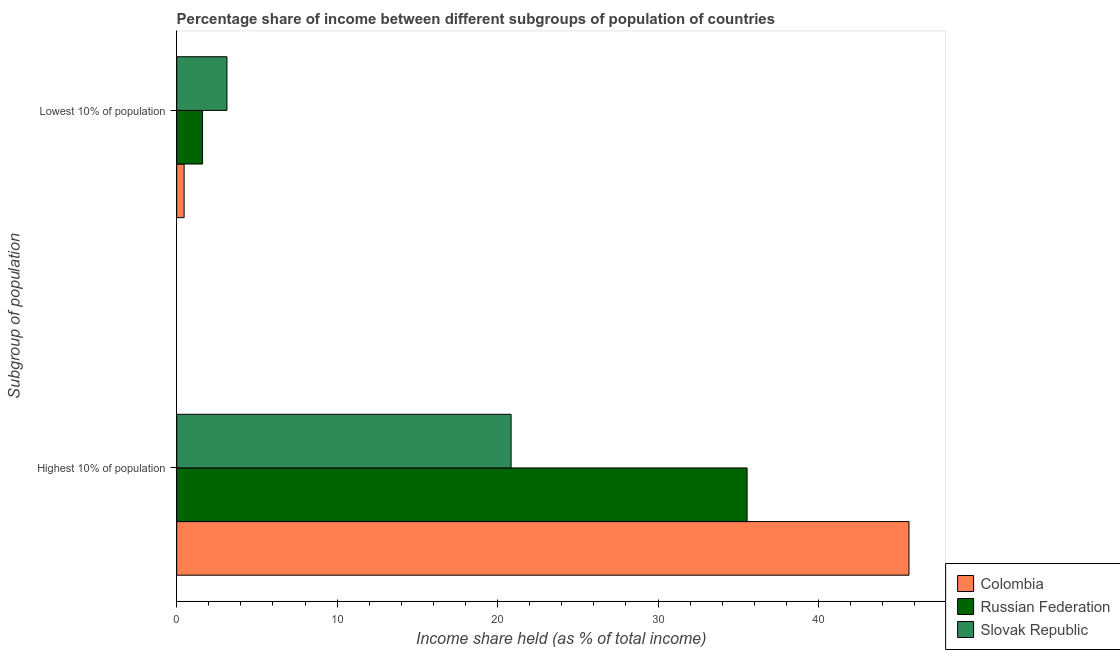How many different coloured bars are there?
Offer a terse response. 3. How many groups of bars are there?
Give a very brief answer. 2. What is the label of the 2nd group of bars from the top?
Give a very brief answer. Highest 10% of population. What is the income share held by highest 10% of the population in Russian Federation?
Keep it short and to the point. 35.55. Across all countries, what is the maximum income share held by highest 10% of the population?
Give a very brief answer. 45.64. Across all countries, what is the minimum income share held by highest 10% of the population?
Your response must be concise. 20.84. In which country was the income share held by lowest 10% of the population maximum?
Give a very brief answer. Slovak Republic. In which country was the income share held by highest 10% of the population minimum?
Keep it short and to the point. Slovak Republic. What is the total income share held by highest 10% of the population in the graph?
Your response must be concise. 102.03. What is the difference between the income share held by highest 10% of the population in Slovak Republic and that in Colombia?
Your response must be concise. -24.8. What is the difference between the income share held by lowest 10% of the population in Slovak Republic and the income share held by highest 10% of the population in Colombia?
Provide a short and direct response. -42.51. What is the average income share held by lowest 10% of the population per country?
Provide a short and direct response. 1.73. What is the difference between the income share held by highest 10% of the population and income share held by lowest 10% of the population in Slovak Republic?
Offer a terse response. 17.71. In how many countries, is the income share held by highest 10% of the population greater than 32 %?
Offer a very short reply. 2. What is the ratio of the income share held by highest 10% of the population in Colombia to that in Slovak Republic?
Offer a terse response. 2.19. Is the income share held by lowest 10% of the population in Slovak Republic less than that in Russian Federation?
Your response must be concise. No. What does the 1st bar from the top in Lowest 10% of population represents?
Provide a short and direct response. Slovak Republic. What does the 1st bar from the bottom in Lowest 10% of population represents?
Keep it short and to the point. Colombia. How many countries are there in the graph?
Your answer should be very brief. 3. What is the difference between two consecutive major ticks on the X-axis?
Make the answer very short. 10. Where does the legend appear in the graph?
Your response must be concise. Bottom right. How many legend labels are there?
Offer a very short reply. 3. How are the legend labels stacked?
Offer a terse response. Vertical. What is the title of the graph?
Provide a succinct answer. Percentage share of income between different subgroups of population of countries. Does "Germany" appear as one of the legend labels in the graph?
Keep it short and to the point. No. What is the label or title of the X-axis?
Your response must be concise. Income share held (as % of total income). What is the label or title of the Y-axis?
Make the answer very short. Subgroup of population. What is the Income share held (as % of total income) in Colombia in Highest 10% of population?
Keep it short and to the point. 45.64. What is the Income share held (as % of total income) of Russian Federation in Highest 10% of population?
Your answer should be very brief. 35.55. What is the Income share held (as % of total income) in Slovak Republic in Highest 10% of population?
Your response must be concise. 20.84. What is the Income share held (as % of total income) of Colombia in Lowest 10% of population?
Your response must be concise. 0.46. What is the Income share held (as % of total income) of Russian Federation in Lowest 10% of population?
Make the answer very short. 1.61. What is the Income share held (as % of total income) in Slovak Republic in Lowest 10% of population?
Give a very brief answer. 3.13. Across all Subgroup of population, what is the maximum Income share held (as % of total income) in Colombia?
Give a very brief answer. 45.64. Across all Subgroup of population, what is the maximum Income share held (as % of total income) of Russian Federation?
Ensure brevity in your answer.  35.55. Across all Subgroup of population, what is the maximum Income share held (as % of total income) in Slovak Republic?
Your answer should be compact. 20.84. Across all Subgroup of population, what is the minimum Income share held (as % of total income) of Colombia?
Your response must be concise. 0.46. Across all Subgroup of population, what is the minimum Income share held (as % of total income) of Russian Federation?
Offer a terse response. 1.61. Across all Subgroup of population, what is the minimum Income share held (as % of total income) of Slovak Republic?
Offer a very short reply. 3.13. What is the total Income share held (as % of total income) in Colombia in the graph?
Ensure brevity in your answer.  46.1. What is the total Income share held (as % of total income) in Russian Federation in the graph?
Give a very brief answer. 37.16. What is the total Income share held (as % of total income) of Slovak Republic in the graph?
Make the answer very short. 23.97. What is the difference between the Income share held (as % of total income) of Colombia in Highest 10% of population and that in Lowest 10% of population?
Your answer should be compact. 45.18. What is the difference between the Income share held (as % of total income) of Russian Federation in Highest 10% of population and that in Lowest 10% of population?
Your answer should be compact. 33.94. What is the difference between the Income share held (as % of total income) of Slovak Republic in Highest 10% of population and that in Lowest 10% of population?
Your answer should be very brief. 17.71. What is the difference between the Income share held (as % of total income) in Colombia in Highest 10% of population and the Income share held (as % of total income) in Russian Federation in Lowest 10% of population?
Keep it short and to the point. 44.03. What is the difference between the Income share held (as % of total income) of Colombia in Highest 10% of population and the Income share held (as % of total income) of Slovak Republic in Lowest 10% of population?
Give a very brief answer. 42.51. What is the difference between the Income share held (as % of total income) of Russian Federation in Highest 10% of population and the Income share held (as % of total income) of Slovak Republic in Lowest 10% of population?
Offer a very short reply. 32.42. What is the average Income share held (as % of total income) of Colombia per Subgroup of population?
Provide a succinct answer. 23.05. What is the average Income share held (as % of total income) in Russian Federation per Subgroup of population?
Your answer should be very brief. 18.58. What is the average Income share held (as % of total income) of Slovak Republic per Subgroup of population?
Offer a terse response. 11.98. What is the difference between the Income share held (as % of total income) in Colombia and Income share held (as % of total income) in Russian Federation in Highest 10% of population?
Your answer should be compact. 10.09. What is the difference between the Income share held (as % of total income) of Colombia and Income share held (as % of total income) of Slovak Republic in Highest 10% of population?
Offer a very short reply. 24.8. What is the difference between the Income share held (as % of total income) of Russian Federation and Income share held (as % of total income) of Slovak Republic in Highest 10% of population?
Offer a very short reply. 14.71. What is the difference between the Income share held (as % of total income) of Colombia and Income share held (as % of total income) of Russian Federation in Lowest 10% of population?
Your answer should be compact. -1.15. What is the difference between the Income share held (as % of total income) in Colombia and Income share held (as % of total income) in Slovak Republic in Lowest 10% of population?
Offer a very short reply. -2.67. What is the difference between the Income share held (as % of total income) in Russian Federation and Income share held (as % of total income) in Slovak Republic in Lowest 10% of population?
Offer a terse response. -1.52. What is the ratio of the Income share held (as % of total income) of Colombia in Highest 10% of population to that in Lowest 10% of population?
Offer a terse response. 99.22. What is the ratio of the Income share held (as % of total income) of Russian Federation in Highest 10% of population to that in Lowest 10% of population?
Provide a succinct answer. 22.08. What is the ratio of the Income share held (as % of total income) of Slovak Republic in Highest 10% of population to that in Lowest 10% of population?
Keep it short and to the point. 6.66. What is the difference between the highest and the second highest Income share held (as % of total income) of Colombia?
Your answer should be very brief. 45.18. What is the difference between the highest and the second highest Income share held (as % of total income) in Russian Federation?
Offer a very short reply. 33.94. What is the difference between the highest and the second highest Income share held (as % of total income) in Slovak Republic?
Give a very brief answer. 17.71. What is the difference between the highest and the lowest Income share held (as % of total income) of Colombia?
Your answer should be compact. 45.18. What is the difference between the highest and the lowest Income share held (as % of total income) in Russian Federation?
Offer a very short reply. 33.94. What is the difference between the highest and the lowest Income share held (as % of total income) of Slovak Republic?
Give a very brief answer. 17.71. 